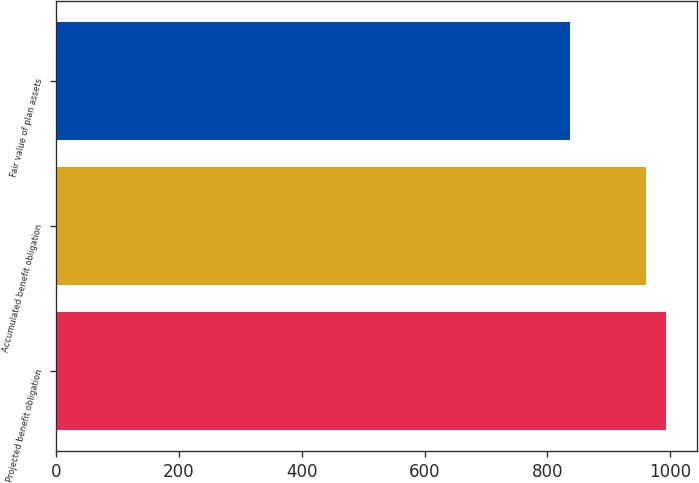Convert chart to OTSL. <chart><loc_0><loc_0><loc_500><loc_500><bar_chart><fcel>Projected benefit obligation<fcel>Accumulated benefit obligation<fcel>Fair value of plan assets<nl><fcel>993<fcel>960<fcel>837<nl></chart> 